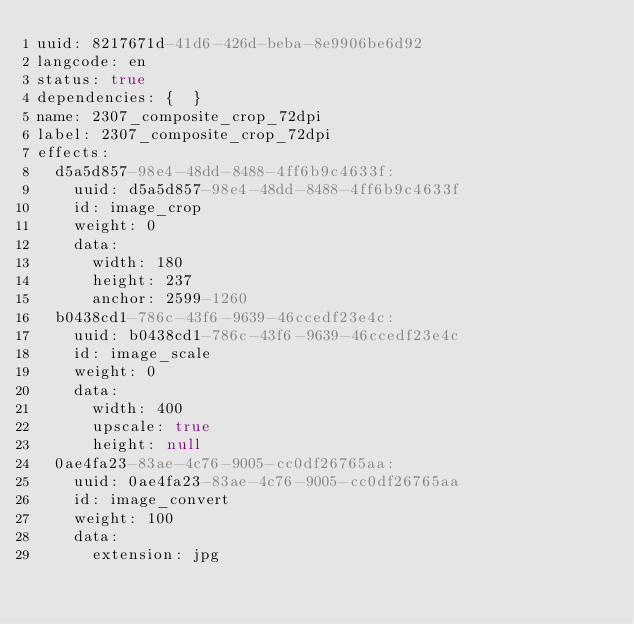<code> <loc_0><loc_0><loc_500><loc_500><_YAML_>uuid: 8217671d-41d6-426d-beba-8e9906be6d92
langcode: en
status: true
dependencies: {  }
name: 2307_composite_crop_72dpi
label: 2307_composite_crop_72dpi
effects:
  d5a5d857-98e4-48dd-8488-4ff6b9c4633f:
    uuid: d5a5d857-98e4-48dd-8488-4ff6b9c4633f
    id: image_crop
    weight: 0
    data:
      width: 180
      height: 237
      anchor: 2599-1260
  b0438cd1-786c-43f6-9639-46ccedf23e4c:
    uuid: b0438cd1-786c-43f6-9639-46ccedf23e4c
    id: image_scale
    weight: 0
    data:
      width: 400
      upscale: true
      height: null
  0ae4fa23-83ae-4c76-9005-cc0df26765aa:
    uuid: 0ae4fa23-83ae-4c76-9005-cc0df26765aa
    id: image_convert
    weight: 100
    data:
      extension: jpg
</code> 